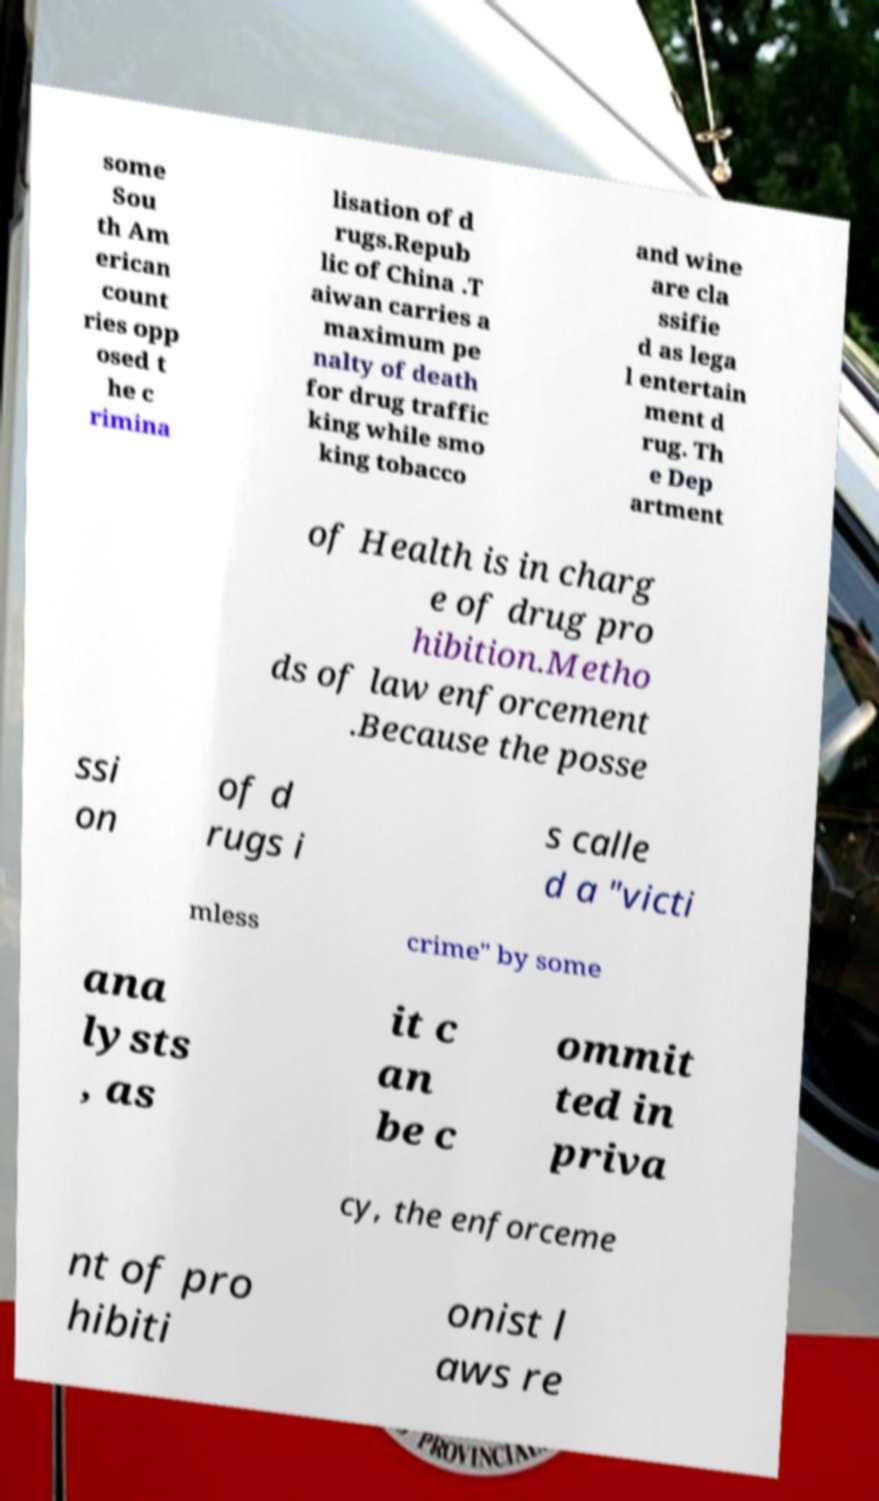Could you extract and type out the text from this image? some Sou th Am erican count ries opp osed t he c rimina lisation of d rugs.Repub lic of China .T aiwan carries a maximum pe nalty of death for drug traffic king while smo king tobacco and wine are cla ssifie d as lega l entertain ment d rug. Th e Dep artment of Health is in charg e of drug pro hibition.Metho ds of law enforcement .Because the posse ssi on of d rugs i s calle d a "victi mless crime" by some ana lysts , as it c an be c ommit ted in priva cy, the enforceme nt of pro hibiti onist l aws re 